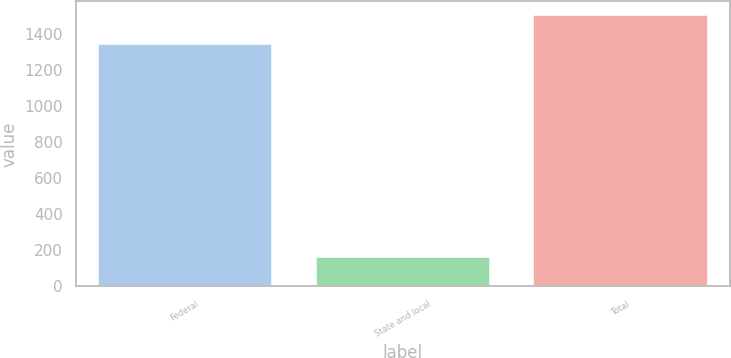Convert chart to OTSL. <chart><loc_0><loc_0><loc_500><loc_500><bar_chart><fcel>Federal<fcel>State and local<fcel>Total<nl><fcel>1344<fcel>161<fcel>1506<nl></chart> 